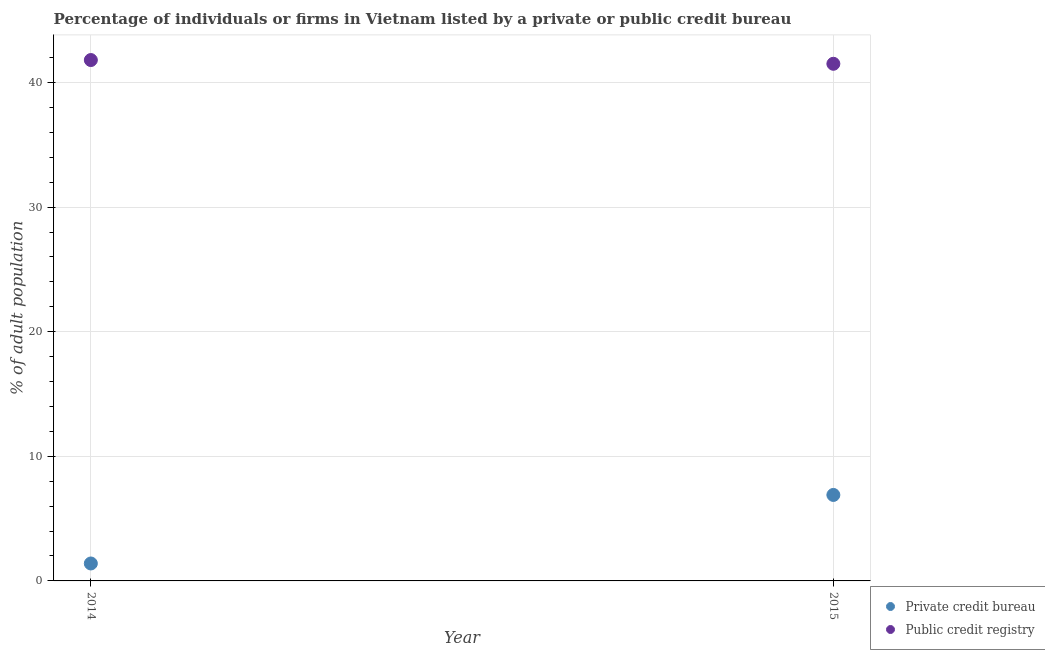Is the number of dotlines equal to the number of legend labels?
Your response must be concise. Yes. What is the percentage of firms listed by public credit bureau in 2015?
Your answer should be very brief. 41.5. Across all years, what is the maximum percentage of firms listed by private credit bureau?
Provide a short and direct response. 6.9. Across all years, what is the minimum percentage of firms listed by private credit bureau?
Make the answer very short. 1.4. In which year was the percentage of firms listed by public credit bureau maximum?
Your response must be concise. 2014. In which year was the percentage of firms listed by private credit bureau minimum?
Offer a terse response. 2014. What is the difference between the percentage of firms listed by public credit bureau in 2014 and that in 2015?
Ensure brevity in your answer.  0.3. What is the difference between the percentage of firms listed by private credit bureau in 2014 and the percentage of firms listed by public credit bureau in 2015?
Provide a short and direct response. -40.1. What is the average percentage of firms listed by public credit bureau per year?
Ensure brevity in your answer.  41.65. In the year 2014, what is the difference between the percentage of firms listed by public credit bureau and percentage of firms listed by private credit bureau?
Your answer should be compact. 40.4. What is the ratio of the percentage of firms listed by private credit bureau in 2014 to that in 2015?
Ensure brevity in your answer.  0.2. Does the percentage of firms listed by private credit bureau monotonically increase over the years?
Keep it short and to the point. Yes. How many dotlines are there?
Offer a very short reply. 2. How are the legend labels stacked?
Your response must be concise. Vertical. What is the title of the graph?
Your answer should be very brief. Percentage of individuals or firms in Vietnam listed by a private or public credit bureau. What is the label or title of the Y-axis?
Offer a terse response. % of adult population. What is the % of adult population in Public credit registry in 2014?
Provide a succinct answer. 41.8. What is the % of adult population in Public credit registry in 2015?
Offer a terse response. 41.5. Across all years, what is the maximum % of adult population in Private credit bureau?
Offer a terse response. 6.9. Across all years, what is the maximum % of adult population in Public credit registry?
Offer a very short reply. 41.8. Across all years, what is the minimum % of adult population of Private credit bureau?
Give a very brief answer. 1.4. Across all years, what is the minimum % of adult population of Public credit registry?
Give a very brief answer. 41.5. What is the total % of adult population of Private credit bureau in the graph?
Keep it short and to the point. 8.3. What is the total % of adult population in Public credit registry in the graph?
Ensure brevity in your answer.  83.3. What is the difference between the % of adult population in Private credit bureau in 2014 and the % of adult population in Public credit registry in 2015?
Your response must be concise. -40.1. What is the average % of adult population of Private credit bureau per year?
Offer a terse response. 4.15. What is the average % of adult population in Public credit registry per year?
Ensure brevity in your answer.  41.65. In the year 2014, what is the difference between the % of adult population in Private credit bureau and % of adult population in Public credit registry?
Give a very brief answer. -40.4. In the year 2015, what is the difference between the % of adult population of Private credit bureau and % of adult population of Public credit registry?
Keep it short and to the point. -34.6. What is the ratio of the % of adult population of Private credit bureau in 2014 to that in 2015?
Your answer should be very brief. 0.2. What is the difference between the highest and the lowest % of adult population in Public credit registry?
Provide a succinct answer. 0.3. 